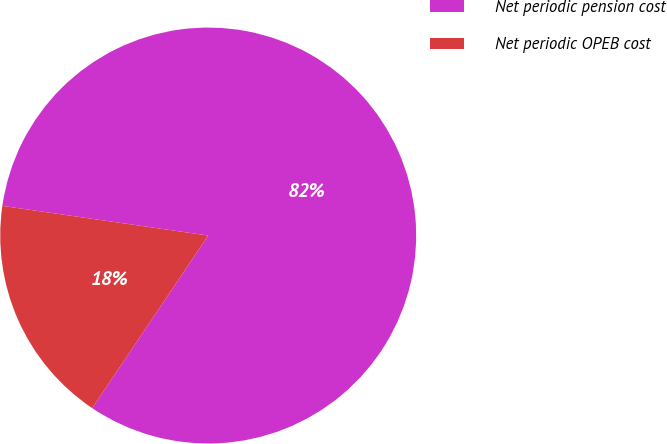Convert chart to OTSL. <chart><loc_0><loc_0><loc_500><loc_500><pie_chart><fcel>Net periodic pension cost<fcel>Net periodic OPEB cost<nl><fcel>82.14%<fcel>17.86%<nl></chart> 